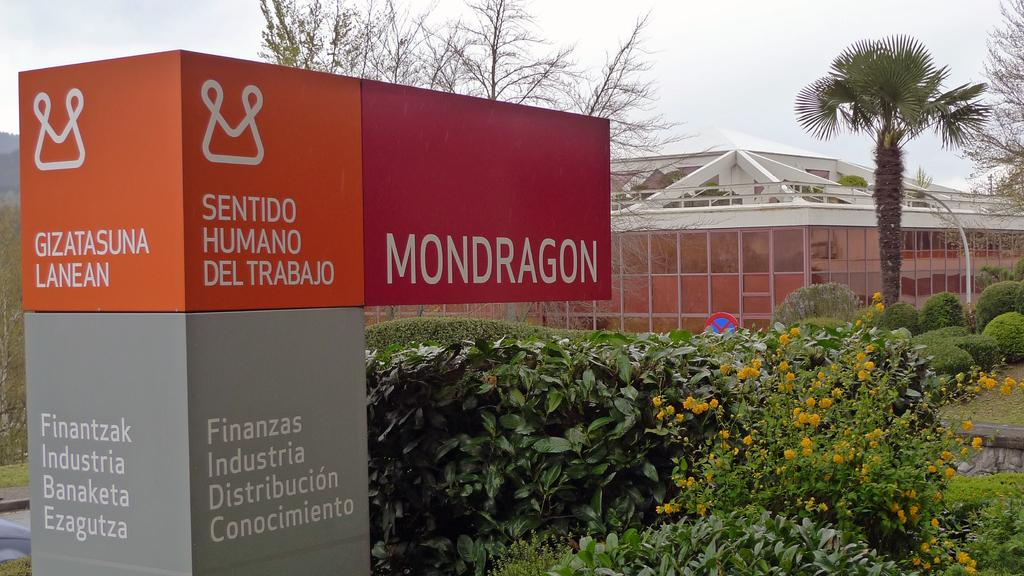What type of objects can be seen in the image? There are boards, plants, flowers, trees, and a building in the image. What kind of vegetation is present in the image? There are plants, flowers, and trees in the image. What can be seen in the background of the image? The sky is visible in the background of the image. What type of coat is the building wearing in the image? There is no coat present in the image, as buildings do not wear clothing. 